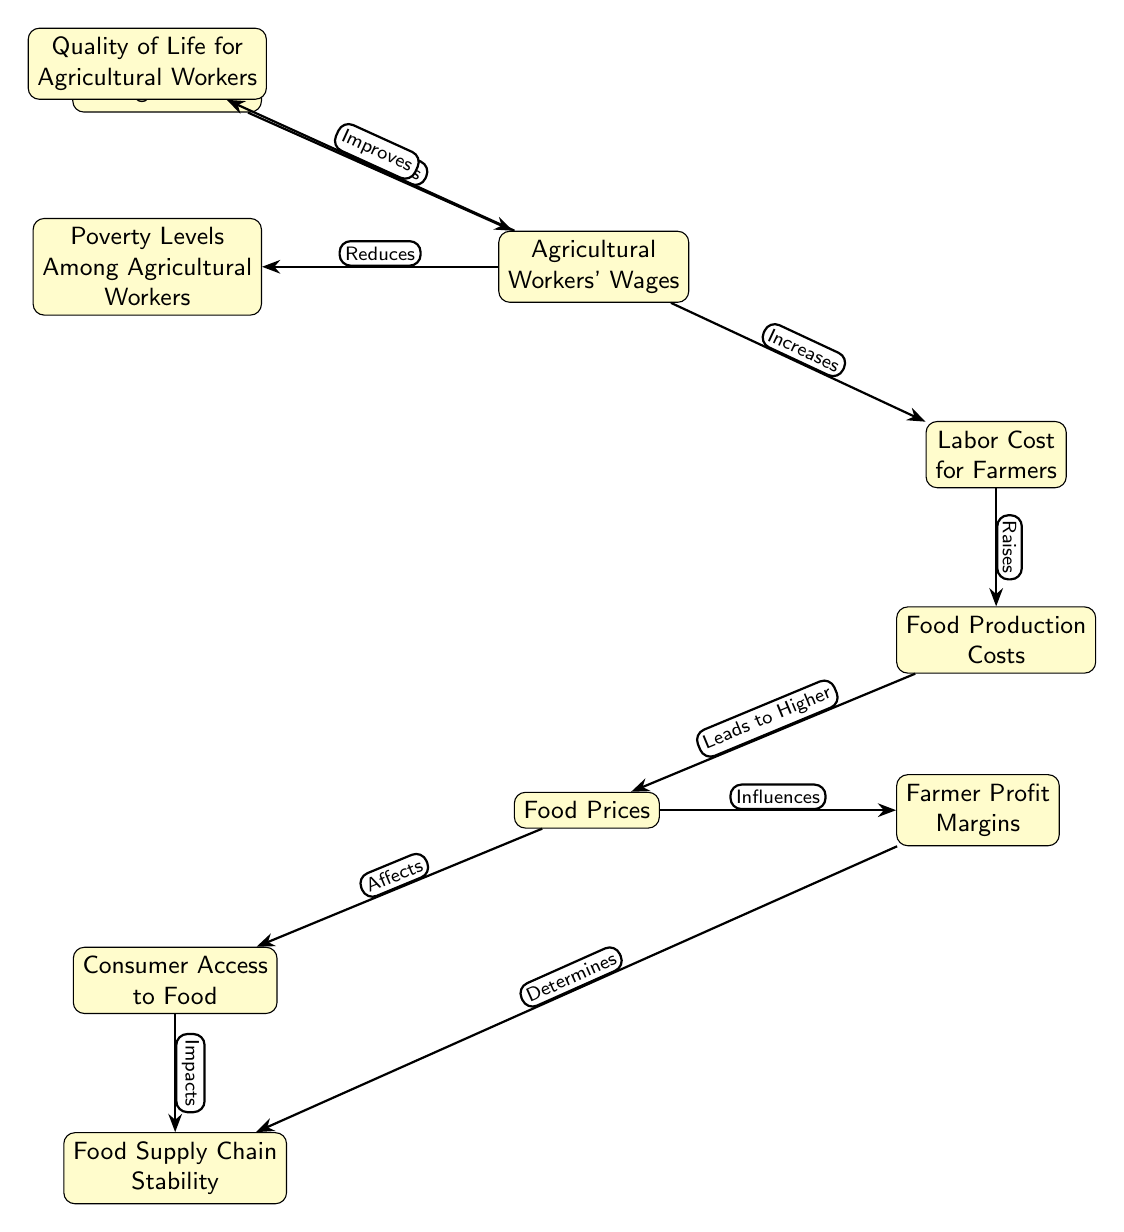What is the first node in the diagram? The first node in the diagram is "Minimum Wage Legislation," as it is positioned at the top and serves as the starting point for the relationships displayed.
Answer: Minimum Wage Legislation How many nodes are in the diagram? The diagram contains a total of 10 nodes, each representing different aspects of the relationship between minimum wage legislation and its effects.
Answer: 10 What relationship exists between Agricultural Workers' Wages and Poverty Levels Among Agricultural Workers? The relationship indicates that an increase in Agricultural Workers' Wages "Reduces" Poverty Levels Among Agricultural Workers, as shown by the directed edge connecting the two nodes.
Answer: Reduces Which node is directly influenced by Food Prices? "Consumer Access to Food" is directly influenced by "Food Prices," as indicated by the edge pointing from Food Prices to Consumer Access to Food in the diagram.
Answer: Consumer Access to Food What does the node "Farmer Profit Margins" influence? "Farmer Profit Margins" influences "Food Supply Chain Stability," meaning that the state of farmer profit margins can impact the overall stability of the food supply chain.
Answer: Food Supply Chain Stability What is indicated to happen as "Food Production Costs" rise? As "Food Production Costs" rise, it "Leads to Higher" Food Prices, indicating a direct consequence shown in the diagram.
Answer: Leads to Higher If Agricultural Workers' Wages improve, what is the expected effect on Quality of Life for Agricultural Workers? The quality of life is expected to "Improve," showing a positive relationship between increased wages and enhanced living conditions for agricultural workers.
Answer: Improves What is a potential result of increased Consumer Access to Food? An increase in Consumer Access to Food can "Impact" Food Supply Chain Stability, demonstrating a relationship where access affects the broader food system.
Answer: Impacts What is the flow of effect from Minimum Wage Legislation to Food Prices? The flow is: Minimum Wage Legislation increases Agricultural Workers' Wages, which raises Labor Costs for Farmers, leads to Food Production Costs, and results in Higher Food Prices. This is a stepwise progression through the nodes.
Answer: Minimum Wage Legislation to Higher Food Prices 